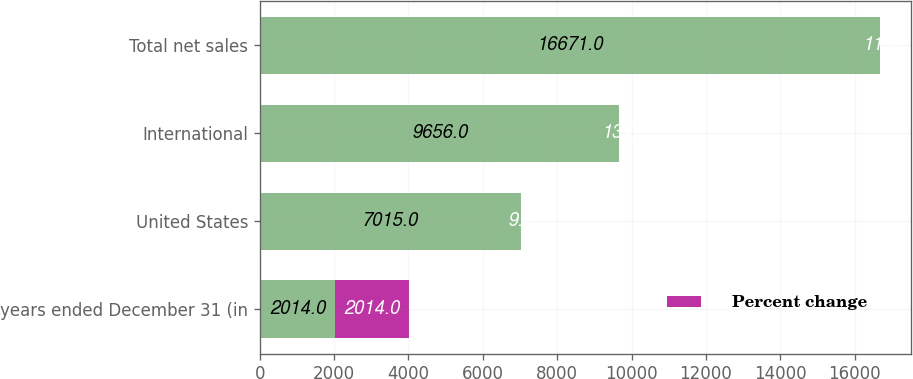Convert chart. <chart><loc_0><loc_0><loc_500><loc_500><stacked_bar_chart><ecel><fcel>years ended December 31 (in<fcel>United States<fcel>International<fcel>Total net sales<nl><fcel>nan<fcel>2014<fcel>7015<fcel>9656<fcel>16671<nl><fcel>Percent change<fcel>2014<fcel>9<fcel>13<fcel>11<nl></chart> 